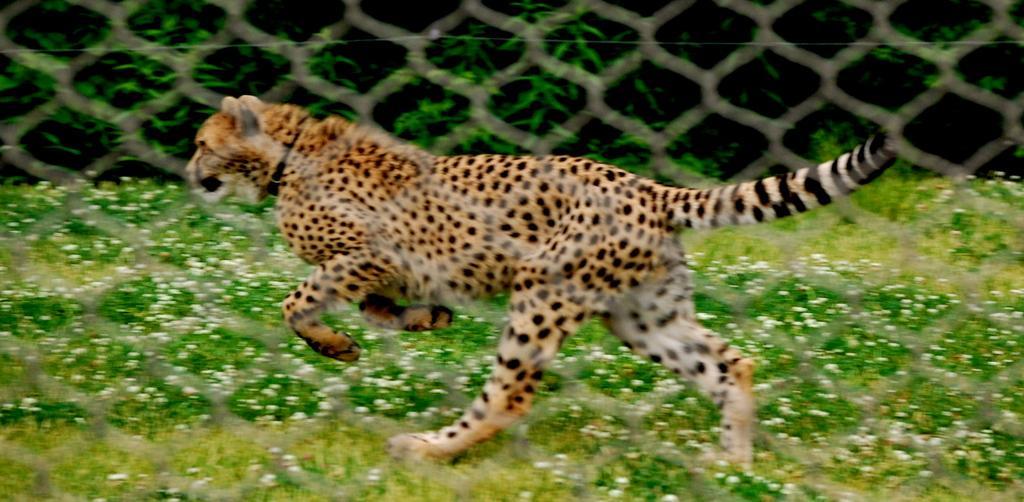Describe this image in one or two sentences. In this image there is a cheetah inside a mesh fence running on the grass surface, on the other side of the cheetah there are trees. 